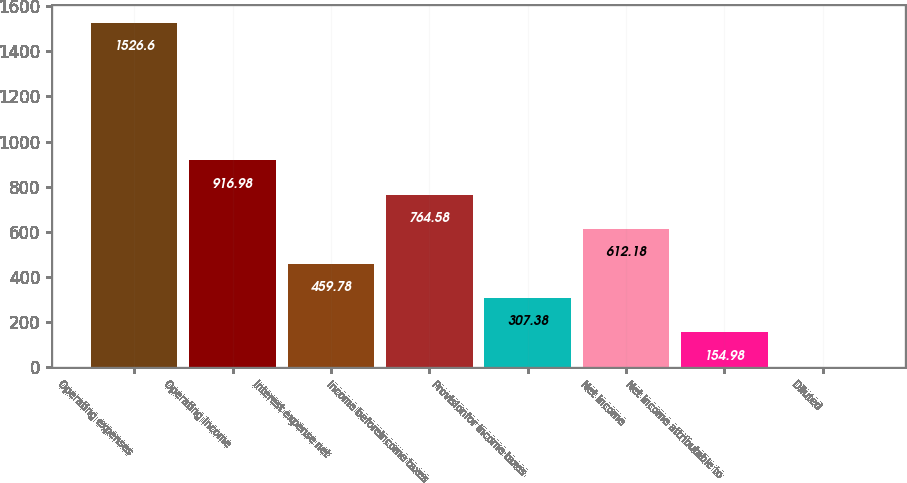Convert chart. <chart><loc_0><loc_0><loc_500><loc_500><bar_chart><fcel>Operating expenses<fcel>Operating income<fcel>Interest expense net<fcel>Income beforeincome taxes<fcel>Provisionfor income taxes<fcel>Net income<fcel>Net income attributable to<fcel>Diluted<nl><fcel>1526.6<fcel>916.98<fcel>459.78<fcel>764.58<fcel>307.38<fcel>612.18<fcel>154.98<fcel>2.58<nl></chart> 